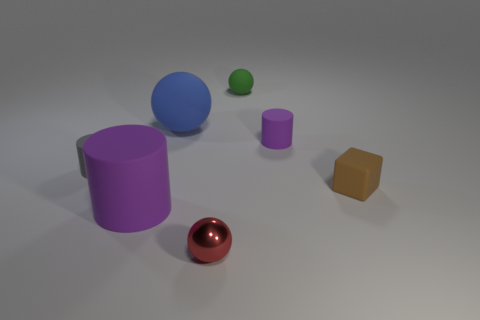What number of cylinders are either big blue matte objects or small purple rubber objects?
Provide a succinct answer. 1. Do the tiny metallic object and the purple thing on the right side of the small rubber ball have the same shape?
Keep it short and to the point. No. There is a sphere that is to the right of the blue rubber object and behind the tiny purple object; what size is it?
Your answer should be very brief. Small. What is the shape of the small purple thing?
Keep it short and to the point. Cylinder. Is there a block that is in front of the matte object that is in front of the brown rubber cube?
Offer a very short reply. No. How many tiny objects are right of the purple rubber cylinder that is to the right of the small green sphere?
Keep it short and to the point. 1. What material is the green thing that is the same size as the shiny ball?
Your answer should be very brief. Rubber. There is a big matte object behind the tiny gray cylinder; is it the same shape as the tiny green object?
Your answer should be very brief. Yes. Are there more tiny red shiny balls that are to the right of the small red shiny sphere than large blue matte spheres on the right side of the large sphere?
Give a very brief answer. No. How many tiny purple cylinders are the same material as the small gray object?
Your response must be concise. 1. 